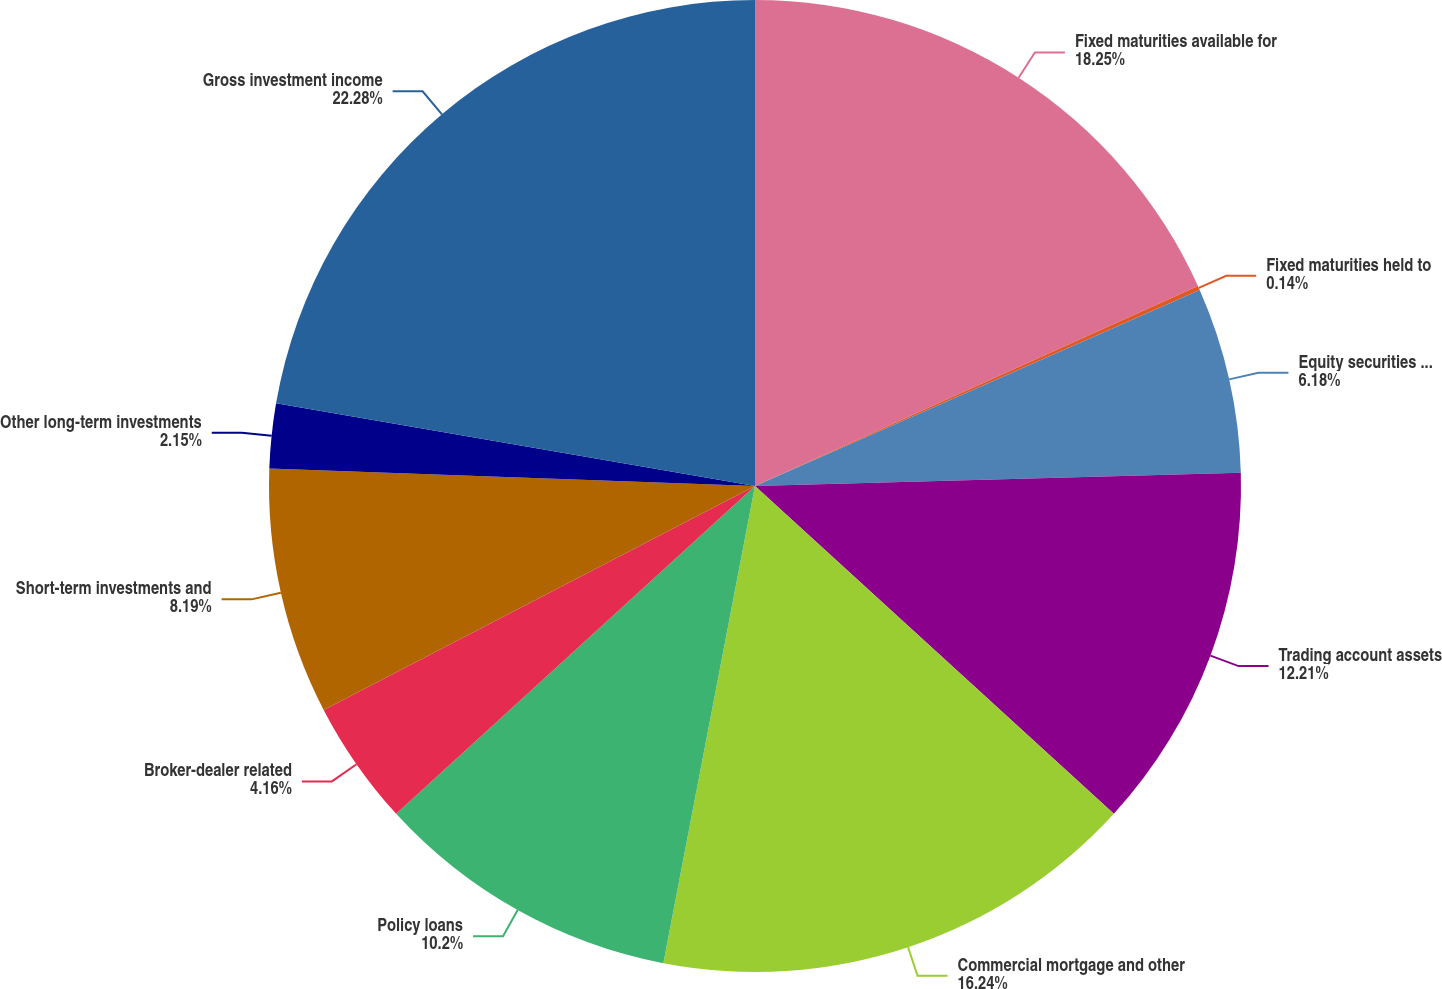Convert chart. <chart><loc_0><loc_0><loc_500><loc_500><pie_chart><fcel>Fixed maturities available for<fcel>Fixed maturities held to<fcel>Equity securities available<fcel>Trading account assets<fcel>Commercial mortgage and other<fcel>Policy loans<fcel>Broker-dealer related<fcel>Short-term investments and<fcel>Other long-term investments<fcel>Gross investment income<nl><fcel>18.25%<fcel>0.14%<fcel>6.18%<fcel>12.21%<fcel>16.24%<fcel>10.2%<fcel>4.16%<fcel>8.19%<fcel>2.15%<fcel>22.28%<nl></chart> 